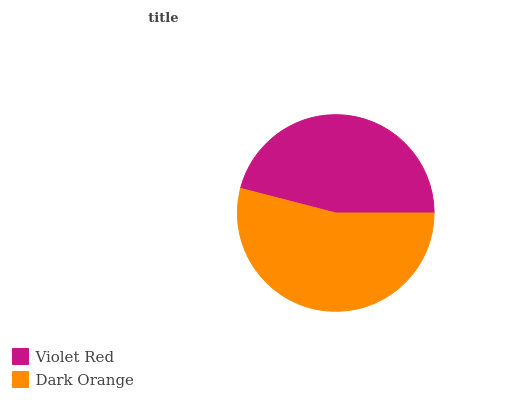Is Violet Red the minimum?
Answer yes or no. Yes. Is Dark Orange the maximum?
Answer yes or no. Yes. Is Dark Orange the minimum?
Answer yes or no. No. Is Dark Orange greater than Violet Red?
Answer yes or no. Yes. Is Violet Red less than Dark Orange?
Answer yes or no. Yes. Is Violet Red greater than Dark Orange?
Answer yes or no. No. Is Dark Orange less than Violet Red?
Answer yes or no. No. Is Dark Orange the high median?
Answer yes or no. Yes. Is Violet Red the low median?
Answer yes or no. Yes. Is Violet Red the high median?
Answer yes or no. No. Is Dark Orange the low median?
Answer yes or no. No. 